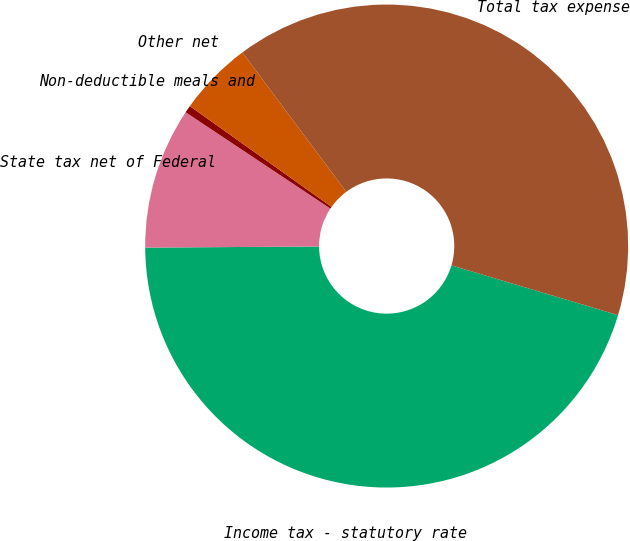<chart> <loc_0><loc_0><loc_500><loc_500><pie_chart><fcel>Income tax - statutory rate<fcel>State tax net of Federal<fcel>Non-deductible meals and<fcel>Other net<fcel>Total tax expense<nl><fcel>45.28%<fcel>9.45%<fcel>0.49%<fcel>4.97%<fcel>39.81%<nl></chart> 